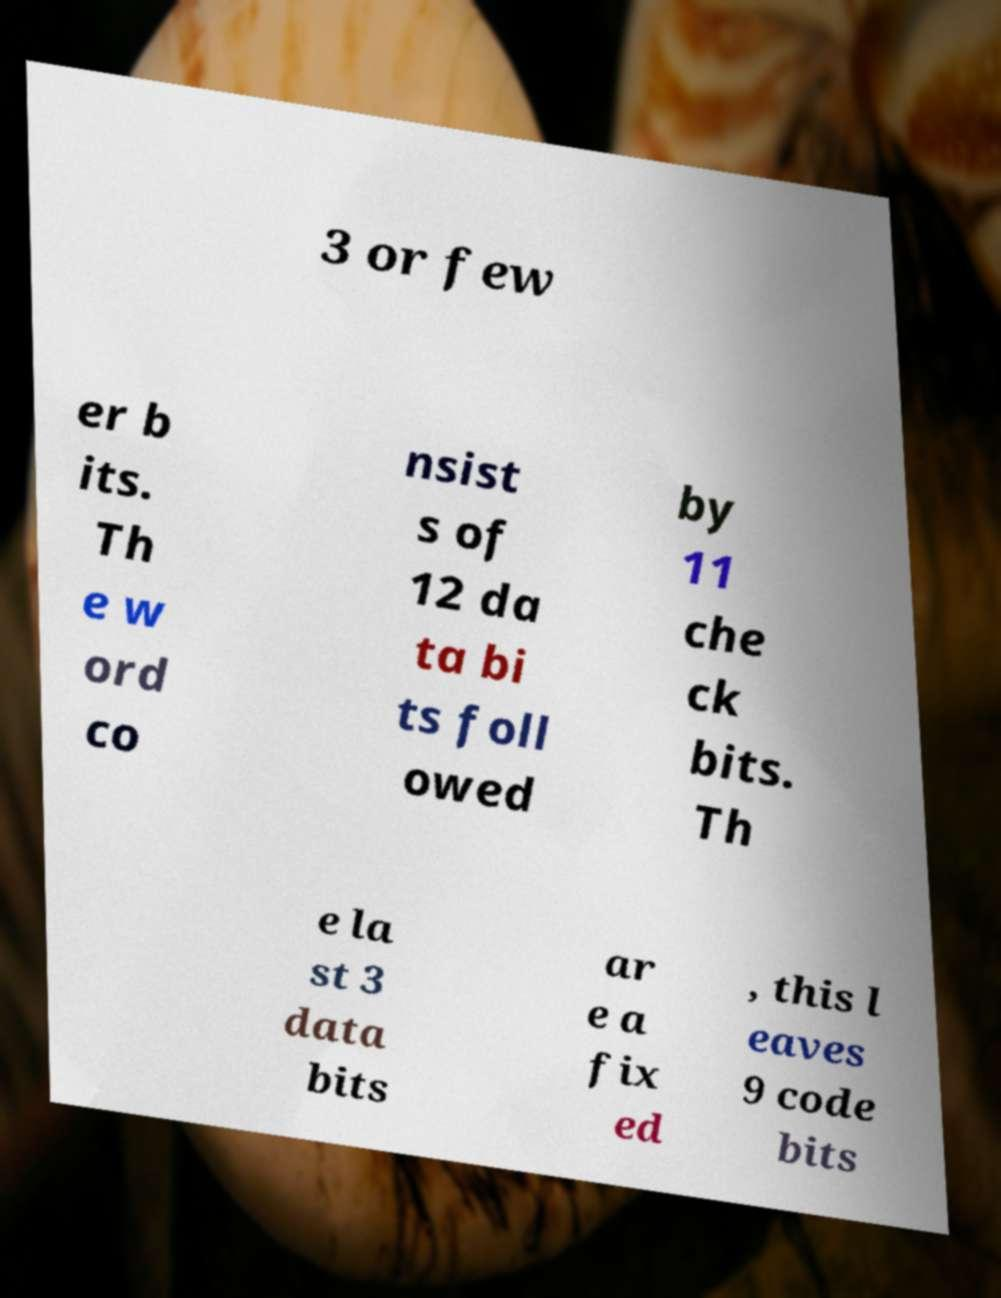There's text embedded in this image that I need extracted. Can you transcribe it verbatim? 3 or few er b its. Th e w ord co nsist s of 12 da ta bi ts foll owed by 11 che ck bits. Th e la st 3 data bits ar e a fix ed , this l eaves 9 code bits 